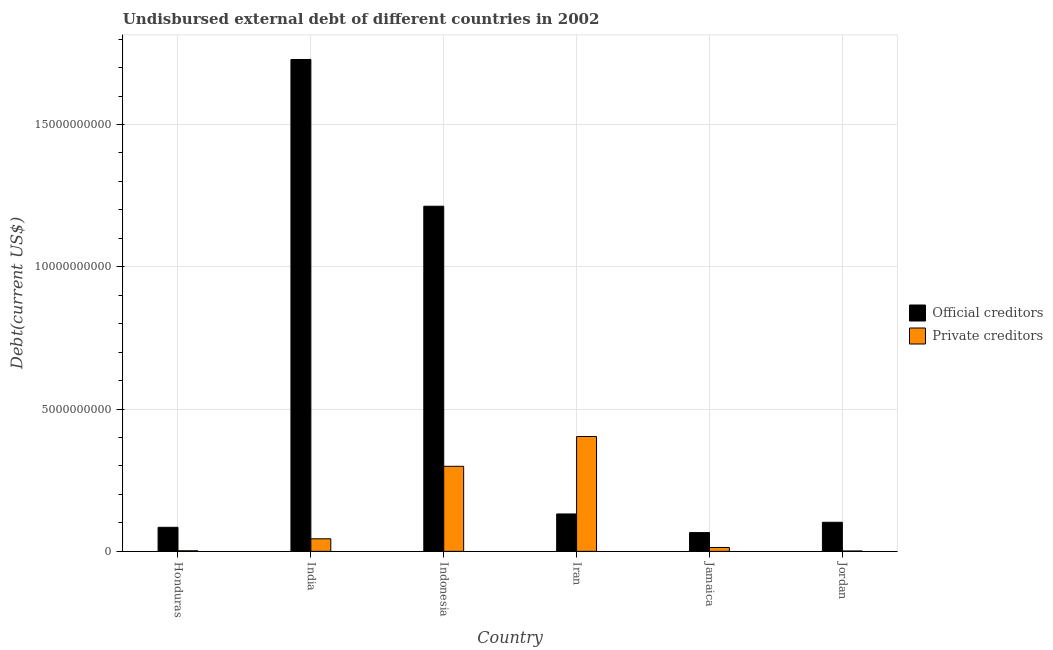How many different coloured bars are there?
Your response must be concise. 2. How many groups of bars are there?
Ensure brevity in your answer.  6. What is the label of the 6th group of bars from the left?
Keep it short and to the point. Jordan. What is the undisbursed external debt of private creditors in Indonesia?
Offer a terse response. 2.99e+09. Across all countries, what is the maximum undisbursed external debt of official creditors?
Make the answer very short. 1.73e+1. Across all countries, what is the minimum undisbursed external debt of official creditors?
Give a very brief answer. 6.60e+08. In which country was the undisbursed external debt of private creditors maximum?
Offer a terse response. Iran. In which country was the undisbursed external debt of official creditors minimum?
Offer a very short reply. Jamaica. What is the total undisbursed external debt of private creditors in the graph?
Make the answer very short. 7.63e+09. What is the difference between the undisbursed external debt of official creditors in Honduras and that in Jordan?
Offer a very short reply. -1.78e+08. What is the difference between the undisbursed external debt of official creditors in Iran and the undisbursed external debt of private creditors in Honduras?
Keep it short and to the point. 1.29e+09. What is the average undisbursed external debt of private creditors per country?
Offer a very short reply. 1.27e+09. What is the difference between the undisbursed external debt of official creditors and undisbursed external debt of private creditors in India?
Offer a very short reply. 1.68e+1. What is the ratio of the undisbursed external debt of private creditors in Indonesia to that in Jamaica?
Your answer should be very brief. 22.03. Is the difference between the undisbursed external debt of official creditors in India and Indonesia greater than the difference between the undisbursed external debt of private creditors in India and Indonesia?
Make the answer very short. Yes. What is the difference between the highest and the second highest undisbursed external debt of official creditors?
Provide a short and direct response. 5.16e+09. What is the difference between the highest and the lowest undisbursed external debt of private creditors?
Make the answer very short. 4.02e+09. Is the sum of the undisbursed external debt of official creditors in Honduras and India greater than the maximum undisbursed external debt of private creditors across all countries?
Your answer should be very brief. Yes. What does the 2nd bar from the left in Honduras represents?
Make the answer very short. Private creditors. What does the 1st bar from the right in Jamaica represents?
Give a very brief answer. Private creditors. Are all the bars in the graph horizontal?
Your answer should be compact. No. What is the difference between two consecutive major ticks on the Y-axis?
Provide a short and direct response. 5.00e+09. Does the graph contain any zero values?
Make the answer very short. No. Where does the legend appear in the graph?
Your response must be concise. Center right. How are the legend labels stacked?
Your response must be concise. Vertical. What is the title of the graph?
Make the answer very short. Undisbursed external debt of different countries in 2002. Does "Under five" appear as one of the legend labels in the graph?
Your answer should be very brief. No. What is the label or title of the Y-axis?
Ensure brevity in your answer.  Debt(current US$). What is the Debt(current US$) in Official creditors in Honduras?
Your answer should be very brief. 8.45e+08. What is the Debt(current US$) in Private creditors in Honduras?
Your answer should be very brief. 2.01e+07. What is the Debt(current US$) in Official creditors in India?
Keep it short and to the point. 1.73e+1. What is the Debt(current US$) of Private creditors in India?
Keep it short and to the point. 4.41e+08. What is the Debt(current US$) in Official creditors in Indonesia?
Your response must be concise. 1.21e+1. What is the Debt(current US$) in Private creditors in Indonesia?
Give a very brief answer. 2.99e+09. What is the Debt(current US$) in Official creditors in Iran?
Provide a succinct answer. 1.31e+09. What is the Debt(current US$) of Private creditors in Iran?
Offer a terse response. 4.04e+09. What is the Debt(current US$) in Official creditors in Jamaica?
Your answer should be compact. 6.60e+08. What is the Debt(current US$) of Private creditors in Jamaica?
Provide a succinct answer. 1.36e+08. What is the Debt(current US$) in Official creditors in Jordan?
Your answer should be compact. 1.02e+09. What is the Debt(current US$) of Private creditors in Jordan?
Your response must be concise. 1.30e+07. Across all countries, what is the maximum Debt(current US$) in Official creditors?
Provide a succinct answer. 1.73e+1. Across all countries, what is the maximum Debt(current US$) in Private creditors?
Your response must be concise. 4.04e+09. Across all countries, what is the minimum Debt(current US$) in Official creditors?
Give a very brief answer. 6.60e+08. Across all countries, what is the minimum Debt(current US$) in Private creditors?
Make the answer very short. 1.30e+07. What is the total Debt(current US$) in Official creditors in the graph?
Provide a short and direct response. 3.33e+1. What is the total Debt(current US$) of Private creditors in the graph?
Provide a short and direct response. 7.63e+09. What is the difference between the Debt(current US$) in Official creditors in Honduras and that in India?
Give a very brief answer. -1.64e+1. What is the difference between the Debt(current US$) in Private creditors in Honduras and that in India?
Ensure brevity in your answer.  -4.21e+08. What is the difference between the Debt(current US$) in Official creditors in Honduras and that in Indonesia?
Offer a terse response. -1.13e+1. What is the difference between the Debt(current US$) in Private creditors in Honduras and that in Indonesia?
Your response must be concise. -2.97e+09. What is the difference between the Debt(current US$) in Official creditors in Honduras and that in Iran?
Keep it short and to the point. -4.70e+08. What is the difference between the Debt(current US$) in Private creditors in Honduras and that in Iran?
Make the answer very short. -4.01e+09. What is the difference between the Debt(current US$) of Official creditors in Honduras and that in Jamaica?
Offer a terse response. 1.85e+08. What is the difference between the Debt(current US$) of Private creditors in Honduras and that in Jamaica?
Provide a short and direct response. -1.16e+08. What is the difference between the Debt(current US$) in Official creditors in Honduras and that in Jordan?
Your answer should be compact. -1.78e+08. What is the difference between the Debt(current US$) in Private creditors in Honduras and that in Jordan?
Make the answer very short. 7.08e+06. What is the difference between the Debt(current US$) in Official creditors in India and that in Indonesia?
Make the answer very short. 5.16e+09. What is the difference between the Debt(current US$) in Private creditors in India and that in Indonesia?
Make the answer very short. -2.55e+09. What is the difference between the Debt(current US$) in Official creditors in India and that in Iran?
Offer a terse response. 1.60e+1. What is the difference between the Debt(current US$) in Private creditors in India and that in Iran?
Give a very brief answer. -3.59e+09. What is the difference between the Debt(current US$) of Official creditors in India and that in Jamaica?
Ensure brevity in your answer.  1.66e+1. What is the difference between the Debt(current US$) of Private creditors in India and that in Jamaica?
Provide a short and direct response. 3.06e+08. What is the difference between the Debt(current US$) in Official creditors in India and that in Jordan?
Give a very brief answer. 1.63e+1. What is the difference between the Debt(current US$) in Private creditors in India and that in Jordan?
Provide a succinct answer. 4.28e+08. What is the difference between the Debt(current US$) in Official creditors in Indonesia and that in Iran?
Offer a terse response. 1.08e+1. What is the difference between the Debt(current US$) in Private creditors in Indonesia and that in Iran?
Your answer should be very brief. -1.05e+09. What is the difference between the Debt(current US$) in Official creditors in Indonesia and that in Jamaica?
Keep it short and to the point. 1.15e+1. What is the difference between the Debt(current US$) in Private creditors in Indonesia and that in Jamaica?
Ensure brevity in your answer.  2.85e+09. What is the difference between the Debt(current US$) in Official creditors in Indonesia and that in Jordan?
Provide a succinct answer. 1.11e+1. What is the difference between the Debt(current US$) of Private creditors in Indonesia and that in Jordan?
Your answer should be compact. 2.98e+09. What is the difference between the Debt(current US$) of Official creditors in Iran and that in Jamaica?
Your response must be concise. 6.54e+08. What is the difference between the Debt(current US$) of Private creditors in Iran and that in Jamaica?
Provide a succinct answer. 3.90e+09. What is the difference between the Debt(current US$) in Official creditors in Iran and that in Jordan?
Ensure brevity in your answer.  2.92e+08. What is the difference between the Debt(current US$) of Private creditors in Iran and that in Jordan?
Give a very brief answer. 4.02e+09. What is the difference between the Debt(current US$) in Official creditors in Jamaica and that in Jordan?
Keep it short and to the point. -3.62e+08. What is the difference between the Debt(current US$) in Private creditors in Jamaica and that in Jordan?
Give a very brief answer. 1.23e+08. What is the difference between the Debt(current US$) of Official creditors in Honduras and the Debt(current US$) of Private creditors in India?
Your answer should be compact. 4.03e+08. What is the difference between the Debt(current US$) of Official creditors in Honduras and the Debt(current US$) of Private creditors in Indonesia?
Give a very brief answer. -2.14e+09. What is the difference between the Debt(current US$) of Official creditors in Honduras and the Debt(current US$) of Private creditors in Iran?
Offer a terse response. -3.19e+09. What is the difference between the Debt(current US$) of Official creditors in Honduras and the Debt(current US$) of Private creditors in Jamaica?
Your answer should be very brief. 7.09e+08. What is the difference between the Debt(current US$) in Official creditors in Honduras and the Debt(current US$) in Private creditors in Jordan?
Your answer should be compact. 8.32e+08. What is the difference between the Debt(current US$) of Official creditors in India and the Debt(current US$) of Private creditors in Indonesia?
Ensure brevity in your answer.  1.43e+1. What is the difference between the Debt(current US$) in Official creditors in India and the Debt(current US$) in Private creditors in Iran?
Your response must be concise. 1.33e+1. What is the difference between the Debt(current US$) of Official creditors in India and the Debt(current US$) of Private creditors in Jamaica?
Provide a succinct answer. 1.72e+1. What is the difference between the Debt(current US$) in Official creditors in India and the Debt(current US$) in Private creditors in Jordan?
Ensure brevity in your answer.  1.73e+1. What is the difference between the Debt(current US$) in Official creditors in Indonesia and the Debt(current US$) in Private creditors in Iran?
Your response must be concise. 8.09e+09. What is the difference between the Debt(current US$) in Official creditors in Indonesia and the Debt(current US$) in Private creditors in Jamaica?
Ensure brevity in your answer.  1.20e+1. What is the difference between the Debt(current US$) of Official creditors in Indonesia and the Debt(current US$) of Private creditors in Jordan?
Your answer should be very brief. 1.21e+1. What is the difference between the Debt(current US$) of Official creditors in Iran and the Debt(current US$) of Private creditors in Jamaica?
Offer a terse response. 1.18e+09. What is the difference between the Debt(current US$) of Official creditors in Iran and the Debt(current US$) of Private creditors in Jordan?
Keep it short and to the point. 1.30e+09. What is the difference between the Debt(current US$) of Official creditors in Jamaica and the Debt(current US$) of Private creditors in Jordan?
Give a very brief answer. 6.47e+08. What is the average Debt(current US$) in Official creditors per country?
Keep it short and to the point. 5.54e+09. What is the average Debt(current US$) of Private creditors per country?
Give a very brief answer. 1.27e+09. What is the difference between the Debt(current US$) of Official creditors and Debt(current US$) of Private creditors in Honduras?
Your answer should be compact. 8.25e+08. What is the difference between the Debt(current US$) of Official creditors and Debt(current US$) of Private creditors in India?
Provide a succinct answer. 1.68e+1. What is the difference between the Debt(current US$) of Official creditors and Debt(current US$) of Private creditors in Indonesia?
Give a very brief answer. 9.14e+09. What is the difference between the Debt(current US$) in Official creditors and Debt(current US$) in Private creditors in Iran?
Your answer should be very brief. -2.72e+09. What is the difference between the Debt(current US$) in Official creditors and Debt(current US$) in Private creditors in Jamaica?
Your answer should be very brief. 5.24e+08. What is the difference between the Debt(current US$) of Official creditors and Debt(current US$) of Private creditors in Jordan?
Ensure brevity in your answer.  1.01e+09. What is the ratio of the Debt(current US$) in Official creditors in Honduras to that in India?
Offer a terse response. 0.05. What is the ratio of the Debt(current US$) in Private creditors in Honduras to that in India?
Provide a succinct answer. 0.05. What is the ratio of the Debt(current US$) in Official creditors in Honduras to that in Indonesia?
Ensure brevity in your answer.  0.07. What is the ratio of the Debt(current US$) of Private creditors in Honduras to that in Indonesia?
Make the answer very short. 0.01. What is the ratio of the Debt(current US$) of Official creditors in Honduras to that in Iran?
Offer a very short reply. 0.64. What is the ratio of the Debt(current US$) in Private creditors in Honduras to that in Iran?
Provide a short and direct response. 0.01. What is the ratio of the Debt(current US$) of Official creditors in Honduras to that in Jamaica?
Provide a succinct answer. 1.28. What is the ratio of the Debt(current US$) of Private creditors in Honduras to that in Jamaica?
Provide a succinct answer. 0.15. What is the ratio of the Debt(current US$) of Official creditors in Honduras to that in Jordan?
Keep it short and to the point. 0.83. What is the ratio of the Debt(current US$) in Private creditors in Honduras to that in Jordan?
Offer a very short reply. 1.55. What is the ratio of the Debt(current US$) of Official creditors in India to that in Indonesia?
Keep it short and to the point. 1.43. What is the ratio of the Debt(current US$) of Private creditors in India to that in Indonesia?
Offer a terse response. 0.15. What is the ratio of the Debt(current US$) in Official creditors in India to that in Iran?
Offer a terse response. 13.15. What is the ratio of the Debt(current US$) in Private creditors in India to that in Iran?
Keep it short and to the point. 0.11. What is the ratio of the Debt(current US$) of Official creditors in India to that in Jamaica?
Offer a very short reply. 26.19. What is the ratio of the Debt(current US$) of Private creditors in India to that in Jamaica?
Offer a terse response. 3.25. What is the ratio of the Debt(current US$) of Official creditors in India to that in Jordan?
Offer a terse response. 16.91. What is the ratio of the Debt(current US$) of Private creditors in India to that in Jordan?
Your answer should be compact. 34. What is the ratio of the Debt(current US$) in Official creditors in Indonesia to that in Iran?
Your answer should be very brief. 9.23. What is the ratio of the Debt(current US$) of Private creditors in Indonesia to that in Iran?
Your answer should be very brief. 0.74. What is the ratio of the Debt(current US$) of Official creditors in Indonesia to that in Jamaica?
Make the answer very short. 18.38. What is the ratio of the Debt(current US$) of Private creditors in Indonesia to that in Jamaica?
Offer a terse response. 22.03. What is the ratio of the Debt(current US$) in Official creditors in Indonesia to that in Jordan?
Keep it short and to the point. 11.87. What is the ratio of the Debt(current US$) of Private creditors in Indonesia to that in Jordan?
Your answer should be very brief. 230.28. What is the ratio of the Debt(current US$) of Official creditors in Iran to that in Jamaica?
Offer a very short reply. 1.99. What is the ratio of the Debt(current US$) in Private creditors in Iran to that in Jamaica?
Your answer should be compact. 29.74. What is the ratio of the Debt(current US$) in Official creditors in Iran to that in Jordan?
Offer a very short reply. 1.29. What is the ratio of the Debt(current US$) of Private creditors in Iran to that in Jordan?
Offer a terse response. 310.86. What is the ratio of the Debt(current US$) in Official creditors in Jamaica to that in Jordan?
Ensure brevity in your answer.  0.65. What is the ratio of the Debt(current US$) of Private creditors in Jamaica to that in Jordan?
Make the answer very short. 10.45. What is the difference between the highest and the second highest Debt(current US$) in Official creditors?
Your answer should be compact. 5.16e+09. What is the difference between the highest and the second highest Debt(current US$) of Private creditors?
Offer a very short reply. 1.05e+09. What is the difference between the highest and the lowest Debt(current US$) of Official creditors?
Provide a short and direct response. 1.66e+1. What is the difference between the highest and the lowest Debt(current US$) in Private creditors?
Keep it short and to the point. 4.02e+09. 